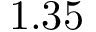Convert formula to latex. <formula><loc_0><loc_0><loc_500><loc_500>1 . 3 5</formula> 